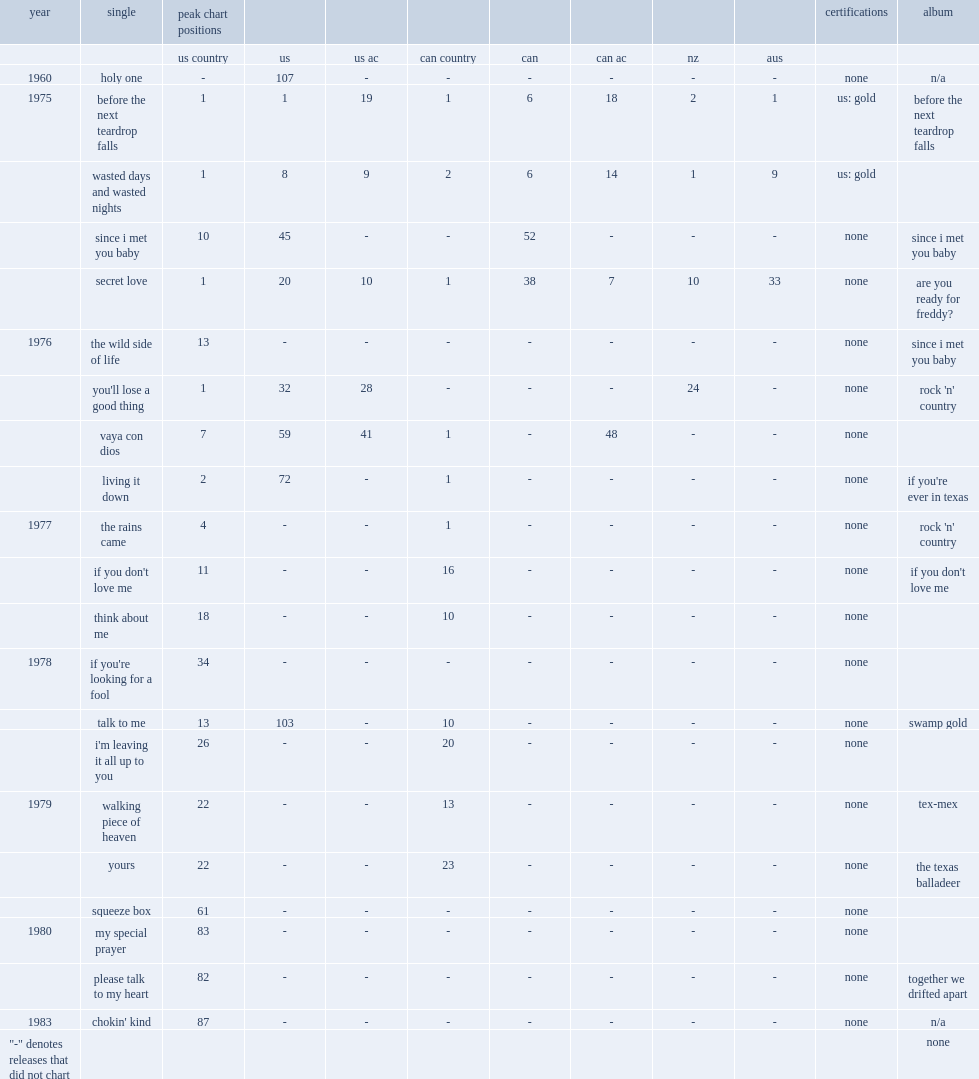When did the single"before the next teardrop falls" release? 1975.0. 